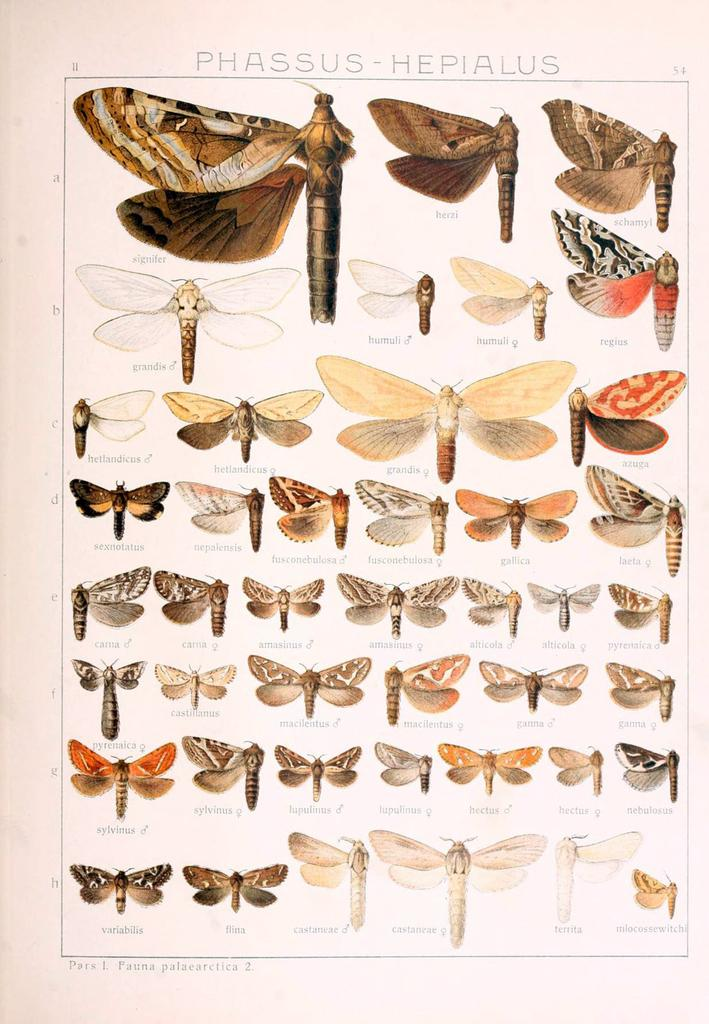What is the main object in the image? There is a banner in the image. What is depicted on the banner? The banner has a painting of butterflies. Are there any words on the banner? Yes, there is writing on the banner. How many fire hydrants are visible in the image? There are no fire hydrants present in the image. What type of work is being done by the butterflies in the painting? The butterflies in the painting are not performing any work, as they are depicted in a natural setting and not engaged in any human-like activities. 